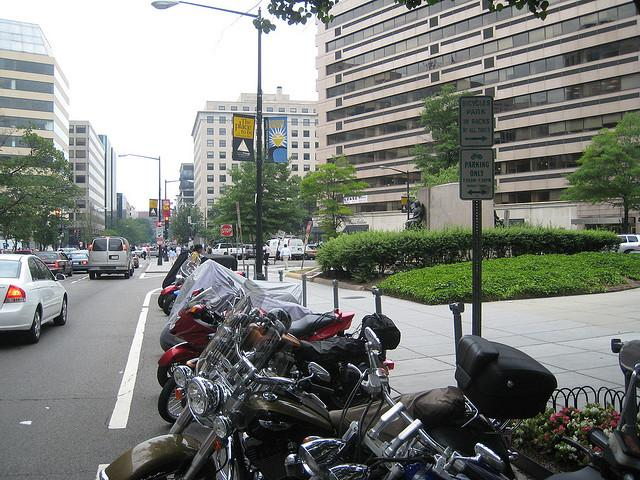What types of people use this part of the street the most?

Choices:
A) taxi drivers
B) truckers
C) motorcyclists
D) pedestrians motorcyclists 